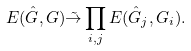Convert formula to latex. <formula><loc_0><loc_0><loc_500><loc_500>E ( \hat { G } , G ) \tilde { \to } \prod _ { i , j } E ( \hat { G } _ { j } , G _ { i } ) .</formula> 